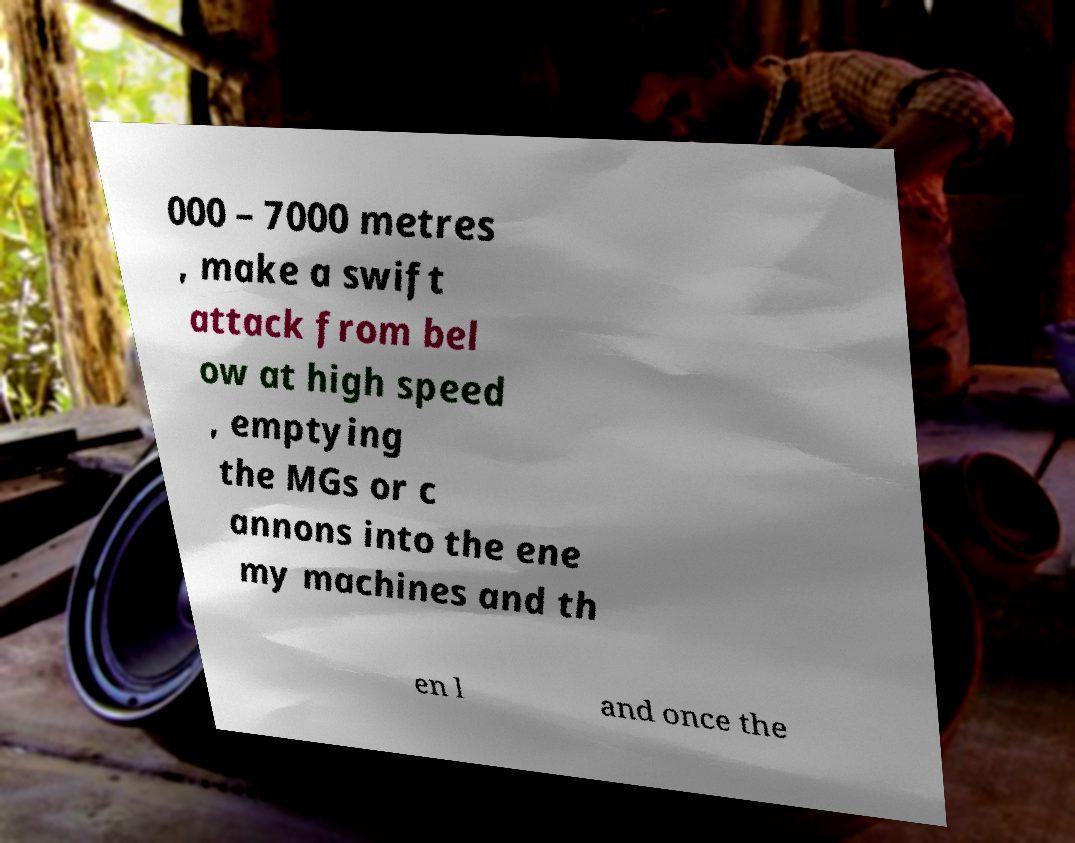Can you accurately transcribe the text from the provided image for me? 000 – 7000 metres , make a swift attack from bel ow at high speed , emptying the MGs or c annons into the ene my machines and th en l and once the 